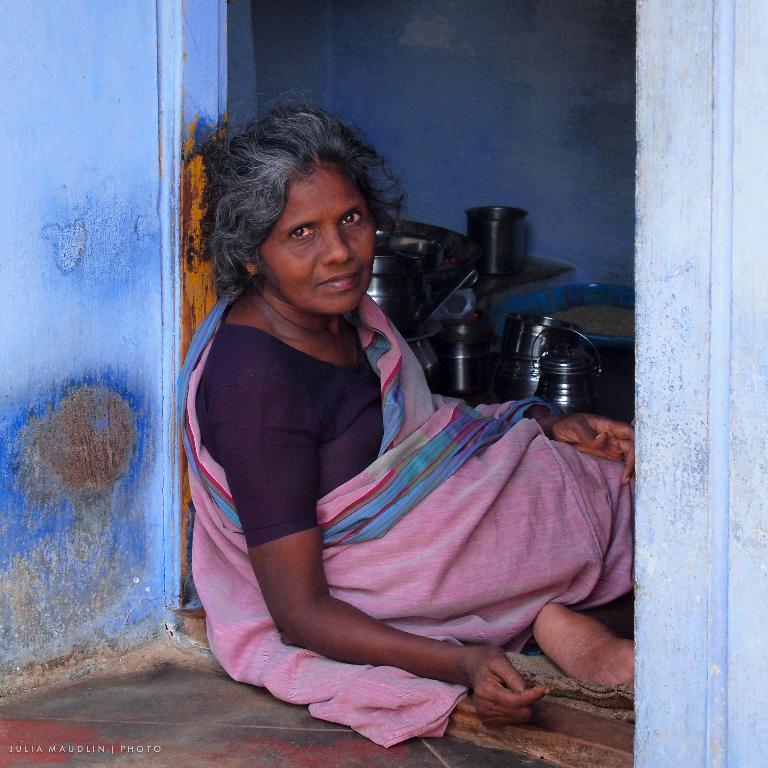What color is the house in the image? The house in the image is blue. Where is the house located in relation to the door? The house is near a door. What is the woman in the image doing? The woman is sitting in the image. What type of items can be seen inside the house? Inside the house, there are steel items visible. What type of cap is the woman wearing in the image? There is no cap visible in the image; the woman is not wearing one. 